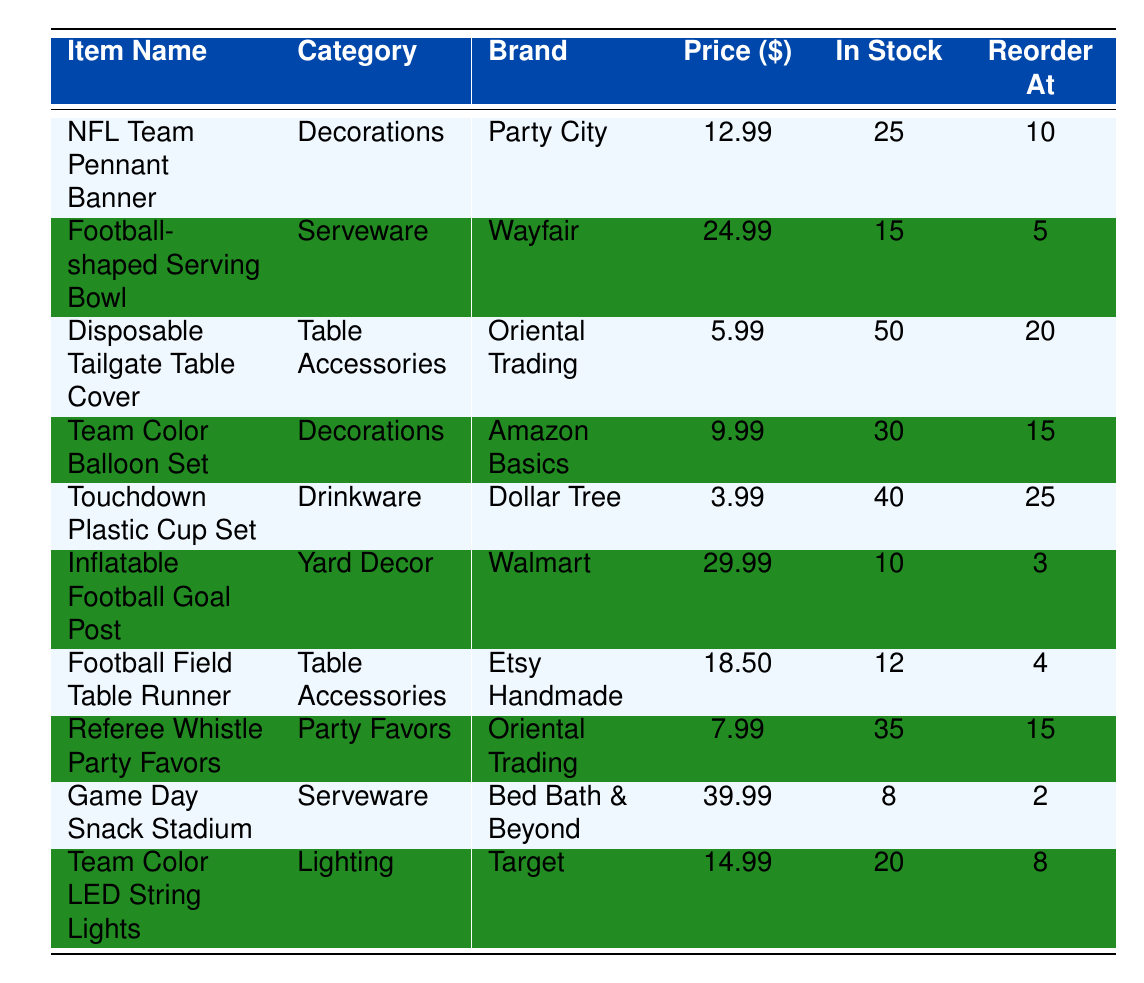What is the price of the Game Day Snack Stadium? The table lists the price of the Game Day Snack Stadium under the column "Price" next to the item's name. It states that the price is 39.99.
Answer: 39.99 How many NFL Team Pennant Banners are in stock? By looking at the "In Stock" column for the NFL Team Pennant Banner, the table shows there are 25 items available.
Answer: 25 Do any items have a reorder threshold of 2? I review the "Reorder At" column to find if any item has a reorder threshold of 2. The Game Day Snack Stadium has a reorder threshold of 2, confirming the answer is yes.
Answer: Yes What is the most expensive item on the list? I compare the prices of all items listed in the "Price" column. The Game Day Snack Stadium at 39.99 is the highest price among all listed items.
Answer: Game Day Snack Stadium What is the total quantity of stock for all decorations? I identify all items categorized as "Decorations" and sum their quantities. The NFL Team Pennant Banner has 25 and the Team Color Balloon Set has 30. The total is 25 + 30 = 55.
Answer: 55 Which brand has the cheapest item? I scan the "Price" column to find the least expensive item, which is the Touchdown Plastic Cup Set priced at 3.99. Its corresponding brand is Dollar Tree.
Answer: Dollar Tree Are there more than 20 Football-shaped Serving Bowls in stock? I check the "In Stock" column for the Football-shaped Serving Bowl, which shows that there are 15 in stock, which is less than 20.
Answer: No What is the average price of all items in the table? I sum all prices: (12.99 + 24.99 + 5.99 + 9.99 + 3.99 + 29.99 + 18.50 + 7.99 + 39.99 + 14.99) = 168.92. There are 10 items, so the average is 168.92 / 10 = 16.89.
Answer: 16.89 What is the difference in stock quantity between the highest and lowest stock items? I observe that the Disposable Tailgate Table Cover has the highest stock at 50, while the Game Day Snack Stadium has the lowest at 8. The difference is 50 - 8 = 42.
Answer: 42 Is there a Team Color LED String Lights in stock? I find that there are 20 items available under the "In Stock" column for Team Color LED String Lights, confirming that it is in stock.
Answer: Yes 